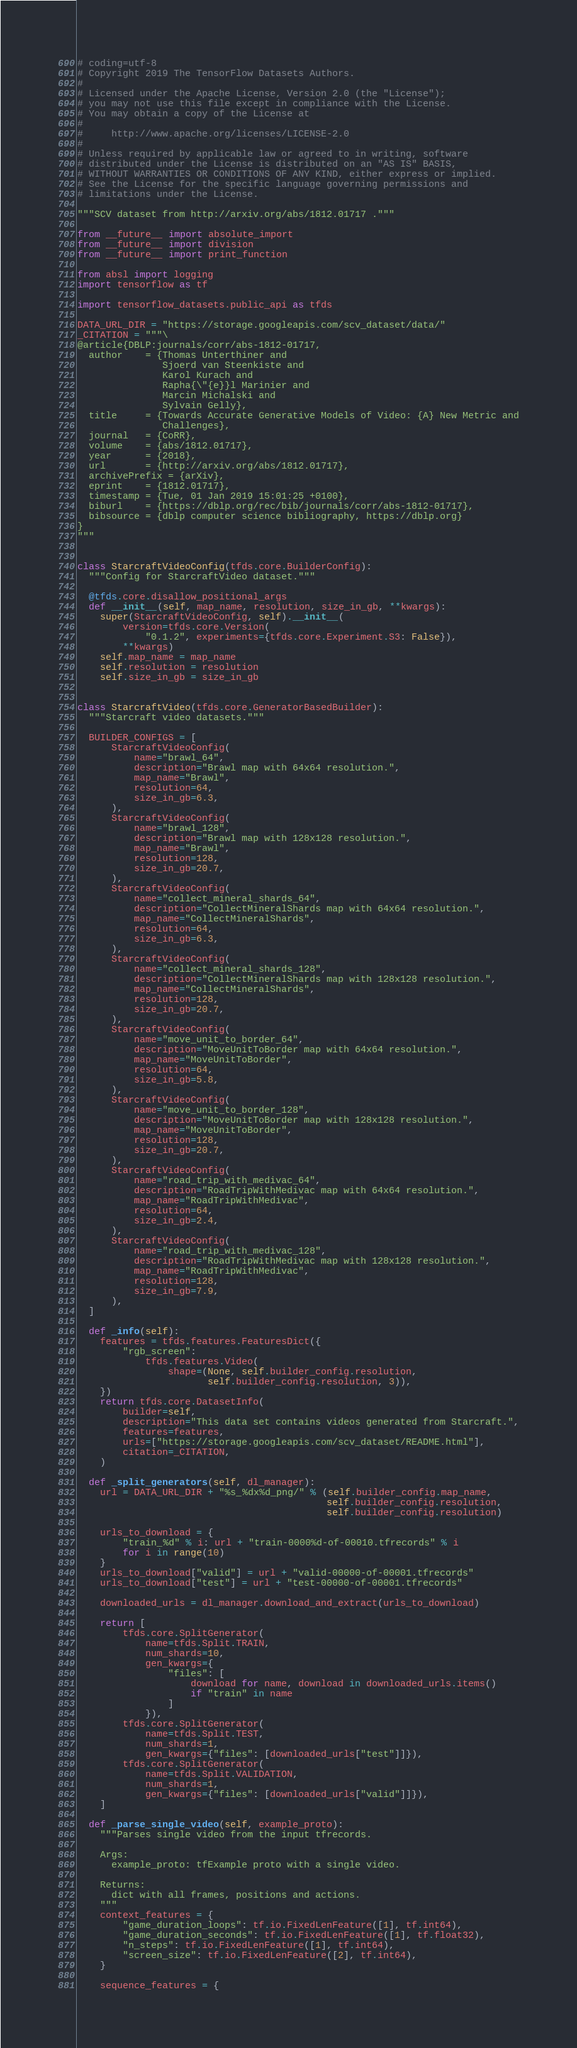Convert code to text. <code><loc_0><loc_0><loc_500><loc_500><_Python_># coding=utf-8
# Copyright 2019 The TensorFlow Datasets Authors.
#
# Licensed under the Apache License, Version 2.0 (the "License");
# you may not use this file except in compliance with the License.
# You may obtain a copy of the License at
#
#     http://www.apache.org/licenses/LICENSE-2.0
#
# Unless required by applicable law or agreed to in writing, software
# distributed under the License is distributed on an "AS IS" BASIS,
# WITHOUT WARRANTIES OR CONDITIONS OF ANY KIND, either express or implied.
# See the License for the specific language governing permissions and
# limitations under the License.

"""SCV dataset from http://arxiv.org/abs/1812.01717 ."""

from __future__ import absolute_import
from __future__ import division
from __future__ import print_function

from absl import logging
import tensorflow as tf

import tensorflow_datasets.public_api as tfds

DATA_URL_DIR = "https://storage.googleapis.com/scv_dataset/data/"
_CITATION = """\
@article{DBLP:journals/corr/abs-1812-01717,
  author    = {Thomas Unterthiner and
               Sjoerd van Steenkiste and
               Karol Kurach and
               Rapha{\"{e}}l Marinier and
               Marcin Michalski and
               Sylvain Gelly},
  title     = {Towards Accurate Generative Models of Video: {A} New Metric and
               Challenges},
  journal   = {CoRR},
  volume    = {abs/1812.01717},
  year      = {2018},
  url       = {http://arxiv.org/abs/1812.01717},
  archivePrefix = {arXiv},
  eprint    = {1812.01717},
  timestamp = {Tue, 01 Jan 2019 15:01:25 +0100},
  biburl    = {https://dblp.org/rec/bib/journals/corr/abs-1812-01717},
  bibsource = {dblp computer science bibliography, https://dblp.org}
}
"""


class StarcraftVideoConfig(tfds.core.BuilderConfig):
  """Config for StarcraftVideo dataset."""

  @tfds.core.disallow_positional_args
  def __init__(self, map_name, resolution, size_in_gb, **kwargs):
    super(StarcraftVideoConfig, self).__init__(
        version=tfds.core.Version(
            "0.1.2", experiments={tfds.core.Experiment.S3: False}),
        **kwargs)
    self.map_name = map_name
    self.resolution = resolution
    self.size_in_gb = size_in_gb


class StarcraftVideo(tfds.core.GeneratorBasedBuilder):
  """Starcraft video datasets."""

  BUILDER_CONFIGS = [
      StarcraftVideoConfig(
          name="brawl_64",
          description="Brawl map with 64x64 resolution.",
          map_name="Brawl",
          resolution=64,
          size_in_gb=6.3,
      ),
      StarcraftVideoConfig(
          name="brawl_128",
          description="Brawl map with 128x128 resolution.",
          map_name="Brawl",
          resolution=128,
          size_in_gb=20.7,
      ),
      StarcraftVideoConfig(
          name="collect_mineral_shards_64",
          description="CollectMineralShards map with 64x64 resolution.",
          map_name="CollectMineralShards",
          resolution=64,
          size_in_gb=6.3,
      ),
      StarcraftVideoConfig(
          name="collect_mineral_shards_128",
          description="CollectMineralShards map with 128x128 resolution.",
          map_name="CollectMineralShards",
          resolution=128,
          size_in_gb=20.7,
      ),
      StarcraftVideoConfig(
          name="move_unit_to_border_64",
          description="MoveUnitToBorder map with 64x64 resolution.",
          map_name="MoveUnitToBorder",
          resolution=64,
          size_in_gb=5.8,
      ),
      StarcraftVideoConfig(
          name="move_unit_to_border_128",
          description="MoveUnitToBorder map with 128x128 resolution.",
          map_name="MoveUnitToBorder",
          resolution=128,
          size_in_gb=20.7,
      ),
      StarcraftVideoConfig(
          name="road_trip_with_medivac_64",
          description="RoadTripWithMedivac map with 64x64 resolution.",
          map_name="RoadTripWithMedivac",
          resolution=64,
          size_in_gb=2.4,
      ),
      StarcraftVideoConfig(
          name="road_trip_with_medivac_128",
          description="RoadTripWithMedivac map with 128x128 resolution.",
          map_name="RoadTripWithMedivac",
          resolution=128,
          size_in_gb=7.9,
      ),
  ]

  def _info(self):
    features = tfds.features.FeaturesDict({
        "rgb_screen":
            tfds.features.Video(
                shape=(None, self.builder_config.resolution,
                       self.builder_config.resolution, 3)),
    })
    return tfds.core.DatasetInfo(
        builder=self,
        description="This data set contains videos generated from Starcraft.",
        features=features,
        urls=["https://storage.googleapis.com/scv_dataset/README.html"],
        citation=_CITATION,
    )

  def _split_generators(self, dl_manager):
    url = DATA_URL_DIR + "%s_%dx%d_png/" % (self.builder_config.map_name,
                                            self.builder_config.resolution,
                                            self.builder_config.resolution)

    urls_to_download = {
        "train_%d" % i: url + "train-0000%d-of-00010.tfrecords" % i
        for i in range(10)
    }
    urls_to_download["valid"] = url + "valid-00000-of-00001.tfrecords"
    urls_to_download["test"] = url + "test-00000-of-00001.tfrecords"

    downloaded_urls = dl_manager.download_and_extract(urls_to_download)

    return [
        tfds.core.SplitGenerator(
            name=tfds.Split.TRAIN,
            num_shards=10,
            gen_kwargs={
                "files": [
                    download for name, download in downloaded_urls.items()
                    if "train" in name
                ]
            }),
        tfds.core.SplitGenerator(
            name=tfds.Split.TEST,
            num_shards=1,
            gen_kwargs={"files": [downloaded_urls["test"]]}),
        tfds.core.SplitGenerator(
            name=tfds.Split.VALIDATION,
            num_shards=1,
            gen_kwargs={"files": [downloaded_urls["valid"]]}),
    ]

  def _parse_single_video(self, example_proto):
    """Parses single video from the input tfrecords.

    Args:
      example_proto: tfExample proto with a single video.

    Returns:
      dict with all frames, positions and actions.
    """
    context_features = {
        "game_duration_loops": tf.io.FixedLenFeature([1], tf.int64),
        "game_duration_seconds": tf.io.FixedLenFeature([1], tf.float32),
        "n_steps": tf.io.FixedLenFeature([1], tf.int64),
        "screen_size": tf.io.FixedLenFeature([2], tf.int64),
    }

    sequence_features = {</code> 